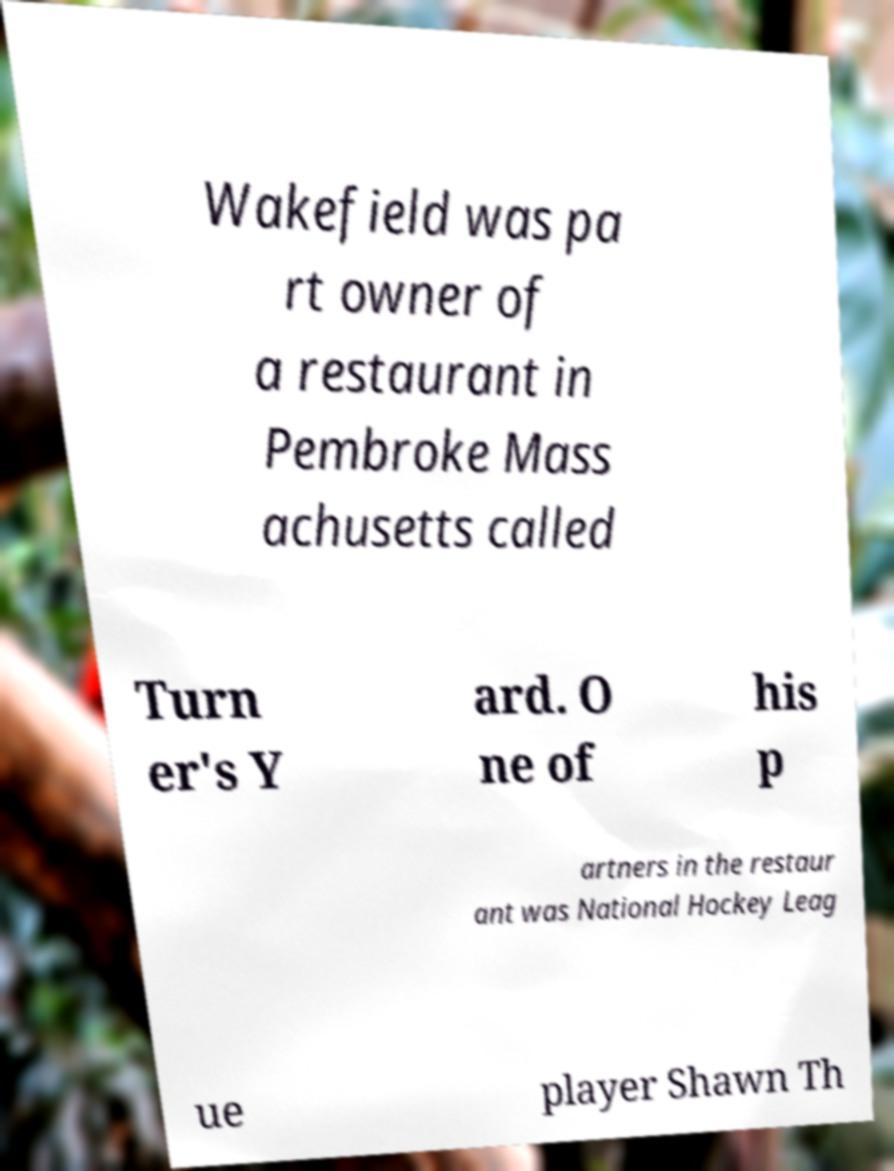Please identify and transcribe the text found in this image. Wakefield was pa rt owner of a restaurant in Pembroke Mass achusetts called Turn er's Y ard. O ne of his p artners in the restaur ant was National Hockey Leag ue player Shawn Th 